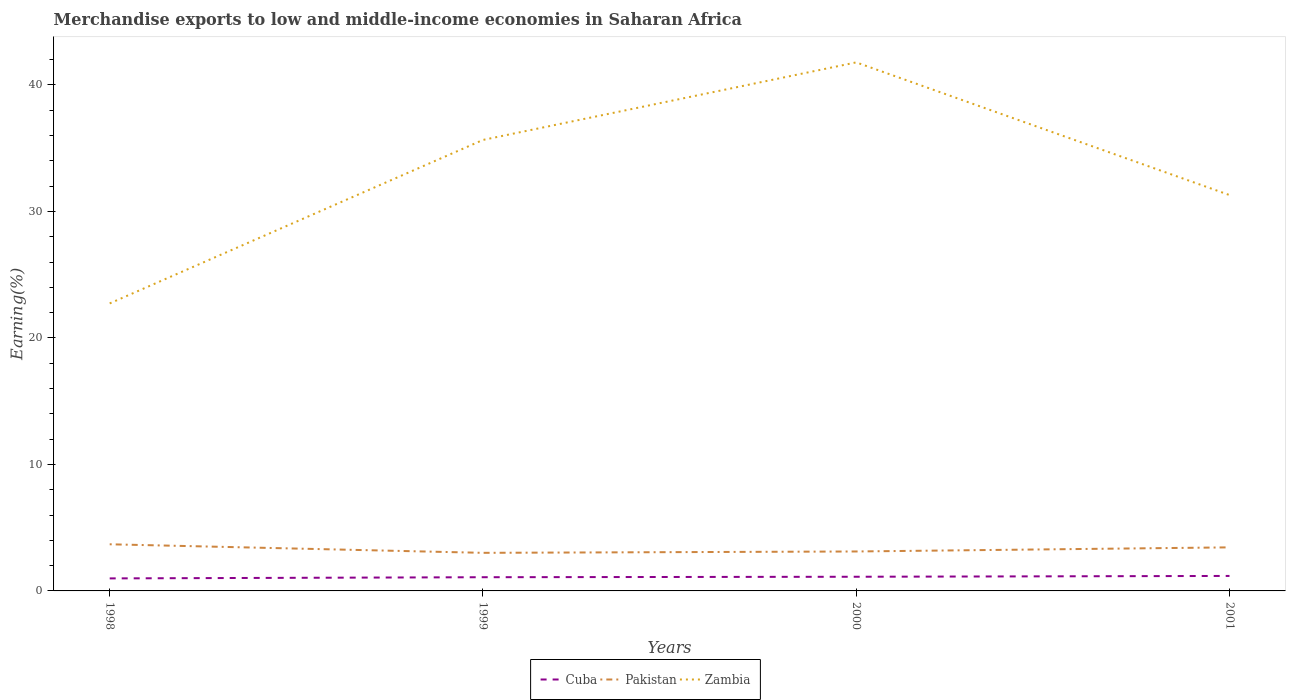How many different coloured lines are there?
Your response must be concise. 3. Is the number of lines equal to the number of legend labels?
Your answer should be compact. Yes. Across all years, what is the maximum percentage of amount earned from merchandise exports in Cuba?
Keep it short and to the point. 0.99. What is the total percentage of amount earned from merchandise exports in Pakistan in the graph?
Your answer should be compact. -0.43. What is the difference between the highest and the second highest percentage of amount earned from merchandise exports in Pakistan?
Keep it short and to the point. 0.68. What is the difference between the highest and the lowest percentage of amount earned from merchandise exports in Pakistan?
Give a very brief answer. 2. Is the percentage of amount earned from merchandise exports in Zambia strictly greater than the percentage of amount earned from merchandise exports in Cuba over the years?
Your answer should be very brief. No. How many lines are there?
Provide a succinct answer. 3. How many years are there in the graph?
Give a very brief answer. 4. What is the difference between two consecutive major ticks on the Y-axis?
Ensure brevity in your answer.  10. Does the graph contain any zero values?
Provide a succinct answer. No. Where does the legend appear in the graph?
Keep it short and to the point. Bottom center. What is the title of the graph?
Make the answer very short. Merchandise exports to low and middle-income economies in Saharan Africa. Does "Germany" appear as one of the legend labels in the graph?
Give a very brief answer. No. What is the label or title of the X-axis?
Your answer should be compact. Years. What is the label or title of the Y-axis?
Your answer should be very brief. Earning(%). What is the Earning(%) of Cuba in 1998?
Offer a terse response. 0.99. What is the Earning(%) in Pakistan in 1998?
Provide a short and direct response. 3.69. What is the Earning(%) in Zambia in 1998?
Offer a terse response. 22.73. What is the Earning(%) of Cuba in 1999?
Offer a terse response. 1.08. What is the Earning(%) in Pakistan in 1999?
Offer a terse response. 3.01. What is the Earning(%) of Zambia in 1999?
Offer a terse response. 35.65. What is the Earning(%) of Cuba in 2000?
Your answer should be compact. 1.12. What is the Earning(%) of Pakistan in 2000?
Make the answer very short. 3.12. What is the Earning(%) of Zambia in 2000?
Provide a succinct answer. 41.78. What is the Earning(%) in Cuba in 2001?
Offer a terse response. 1.18. What is the Earning(%) in Pakistan in 2001?
Offer a terse response. 3.44. What is the Earning(%) of Zambia in 2001?
Provide a succinct answer. 31.29. Across all years, what is the maximum Earning(%) in Cuba?
Offer a terse response. 1.18. Across all years, what is the maximum Earning(%) in Pakistan?
Offer a terse response. 3.69. Across all years, what is the maximum Earning(%) in Zambia?
Your answer should be very brief. 41.78. Across all years, what is the minimum Earning(%) of Cuba?
Your answer should be very brief. 0.99. Across all years, what is the minimum Earning(%) of Pakistan?
Your response must be concise. 3.01. Across all years, what is the minimum Earning(%) of Zambia?
Your answer should be very brief. 22.73. What is the total Earning(%) of Cuba in the graph?
Keep it short and to the point. 4.38. What is the total Earning(%) in Pakistan in the graph?
Make the answer very short. 13.26. What is the total Earning(%) in Zambia in the graph?
Provide a succinct answer. 131.45. What is the difference between the Earning(%) in Cuba in 1998 and that in 1999?
Your answer should be compact. -0.09. What is the difference between the Earning(%) in Pakistan in 1998 and that in 1999?
Offer a terse response. 0.68. What is the difference between the Earning(%) of Zambia in 1998 and that in 1999?
Give a very brief answer. -12.92. What is the difference between the Earning(%) in Cuba in 1998 and that in 2000?
Your response must be concise. -0.13. What is the difference between the Earning(%) in Pakistan in 1998 and that in 2000?
Offer a terse response. 0.57. What is the difference between the Earning(%) of Zambia in 1998 and that in 2000?
Ensure brevity in your answer.  -19.05. What is the difference between the Earning(%) of Cuba in 1998 and that in 2001?
Offer a very short reply. -0.19. What is the difference between the Earning(%) in Pakistan in 1998 and that in 2001?
Your answer should be very brief. 0.24. What is the difference between the Earning(%) in Zambia in 1998 and that in 2001?
Provide a short and direct response. -8.57. What is the difference between the Earning(%) in Cuba in 1999 and that in 2000?
Offer a very short reply. -0.04. What is the difference between the Earning(%) of Pakistan in 1999 and that in 2000?
Provide a short and direct response. -0.11. What is the difference between the Earning(%) in Zambia in 1999 and that in 2000?
Offer a very short reply. -6.13. What is the difference between the Earning(%) in Cuba in 1999 and that in 2001?
Make the answer very short. -0.1. What is the difference between the Earning(%) of Pakistan in 1999 and that in 2001?
Your answer should be compact. -0.43. What is the difference between the Earning(%) of Zambia in 1999 and that in 2001?
Provide a short and direct response. 4.36. What is the difference between the Earning(%) of Cuba in 2000 and that in 2001?
Provide a succinct answer. -0.06. What is the difference between the Earning(%) in Pakistan in 2000 and that in 2001?
Offer a terse response. -0.32. What is the difference between the Earning(%) of Zambia in 2000 and that in 2001?
Your response must be concise. 10.49. What is the difference between the Earning(%) of Cuba in 1998 and the Earning(%) of Pakistan in 1999?
Ensure brevity in your answer.  -2.02. What is the difference between the Earning(%) of Cuba in 1998 and the Earning(%) of Zambia in 1999?
Give a very brief answer. -34.66. What is the difference between the Earning(%) of Pakistan in 1998 and the Earning(%) of Zambia in 1999?
Ensure brevity in your answer.  -31.96. What is the difference between the Earning(%) in Cuba in 1998 and the Earning(%) in Pakistan in 2000?
Your response must be concise. -2.13. What is the difference between the Earning(%) of Cuba in 1998 and the Earning(%) of Zambia in 2000?
Give a very brief answer. -40.79. What is the difference between the Earning(%) in Pakistan in 1998 and the Earning(%) in Zambia in 2000?
Provide a succinct answer. -38.09. What is the difference between the Earning(%) in Cuba in 1998 and the Earning(%) in Pakistan in 2001?
Your answer should be compact. -2.45. What is the difference between the Earning(%) of Cuba in 1998 and the Earning(%) of Zambia in 2001?
Keep it short and to the point. -30.3. What is the difference between the Earning(%) in Pakistan in 1998 and the Earning(%) in Zambia in 2001?
Provide a succinct answer. -27.61. What is the difference between the Earning(%) in Cuba in 1999 and the Earning(%) in Pakistan in 2000?
Ensure brevity in your answer.  -2.04. What is the difference between the Earning(%) in Cuba in 1999 and the Earning(%) in Zambia in 2000?
Offer a very short reply. -40.7. What is the difference between the Earning(%) in Pakistan in 1999 and the Earning(%) in Zambia in 2000?
Provide a short and direct response. -38.77. What is the difference between the Earning(%) of Cuba in 1999 and the Earning(%) of Pakistan in 2001?
Keep it short and to the point. -2.36. What is the difference between the Earning(%) of Cuba in 1999 and the Earning(%) of Zambia in 2001?
Your answer should be very brief. -30.21. What is the difference between the Earning(%) of Pakistan in 1999 and the Earning(%) of Zambia in 2001?
Offer a very short reply. -28.28. What is the difference between the Earning(%) in Cuba in 2000 and the Earning(%) in Pakistan in 2001?
Offer a terse response. -2.32. What is the difference between the Earning(%) in Cuba in 2000 and the Earning(%) in Zambia in 2001?
Ensure brevity in your answer.  -30.17. What is the difference between the Earning(%) in Pakistan in 2000 and the Earning(%) in Zambia in 2001?
Give a very brief answer. -28.17. What is the average Earning(%) of Cuba per year?
Your answer should be compact. 1.09. What is the average Earning(%) of Pakistan per year?
Make the answer very short. 3.31. What is the average Earning(%) of Zambia per year?
Make the answer very short. 32.86. In the year 1998, what is the difference between the Earning(%) in Cuba and Earning(%) in Pakistan?
Ensure brevity in your answer.  -2.7. In the year 1998, what is the difference between the Earning(%) of Cuba and Earning(%) of Zambia?
Make the answer very short. -21.74. In the year 1998, what is the difference between the Earning(%) in Pakistan and Earning(%) in Zambia?
Provide a short and direct response. -19.04. In the year 1999, what is the difference between the Earning(%) of Cuba and Earning(%) of Pakistan?
Keep it short and to the point. -1.93. In the year 1999, what is the difference between the Earning(%) of Cuba and Earning(%) of Zambia?
Your answer should be compact. -34.57. In the year 1999, what is the difference between the Earning(%) in Pakistan and Earning(%) in Zambia?
Your answer should be compact. -32.64. In the year 2000, what is the difference between the Earning(%) of Cuba and Earning(%) of Pakistan?
Provide a succinct answer. -2. In the year 2000, what is the difference between the Earning(%) of Cuba and Earning(%) of Zambia?
Offer a very short reply. -40.66. In the year 2000, what is the difference between the Earning(%) in Pakistan and Earning(%) in Zambia?
Ensure brevity in your answer.  -38.66. In the year 2001, what is the difference between the Earning(%) in Cuba and Earning(%) in Pakistan?
Your response must be concise. -2.26. In the year 2001, what is the difference between the Earning(%) in Cuba and Earning(%) in Zambia?
Ensure brevity in your answer.  -30.11. In the year 2001, what is the difference between the Earning(%) of Pakistan and Earning(%) of Zambia?
Provide a short and direct response. -27.85. What is the ratio of the Earning(%) in Cuba in 1998 to that in 1999?
Provide a succinct answer. 0.91. What is the ratio of the Earning(%) in Pakistan in 1998 to that in 1999?
Your answer should be very brief. 1.22. What is the ratio of the Earning(%) in Zambia in 1998 to that in 1999?
Ensure brevity in your answer.  0.64. What is the ratio of the Earning(%) of Cuba in 1998 to that in 2000?
Offer a terse response. 0.88. What is the ratio of the Earning(%) in Pakistan in 1998 to that in 2000?
Your response must be concise. 1.18. What is the ratio of the Earning(%) of Zambia in 1998 to that in 2000?
Offer a very short reply. 0.54. What is the ratio of the Earning(%) in Cuba in 1998 to that in 2001?
Make the answer very short. 0.84. What is the ratio of the Earning(%) in Pakistan in 1998 to that in 2001?
Your answer should be compact. 1.07. What is the ratio of the Earning(%) in Zambia in 1998 to that in 2001?
Offer a terse response. 0.73. What is the ratio of the Earning(%) of Cuba in 1999 to that in 2000?
Give a very brief answer. 0.97. What is the ratio of the Earning(%) of Pakistan in 1999 to that in 2000?
Offer a terse response. 0.97. What is the ratio of the Earning(%) in Zambia in 1999 to that in 2000?
Provide a short and direct response. 0.85. What is the ratio of the Earning(%) of Cuba in 1999 to that in 2001?
Offer a terse response. 0.91. What is the ratio of the Earning(%) of Pakistan in 1999 to that in 2001?
Offer a terse response. 0.87. What is the ratio of the Earning(%) in Zambia in 1999 to that in 2001?
Provide a succinct answer. 1.14. What is the ratio of the Earning(%) in Cuba in 2000 to that in 2001?
Give a very brief answer. 0.95. What is the ratio of the Earning(%) in Pakistan in 2000 to that in 2001?
Keep it short and to the point. 0.91. What is the ratio of the Earning(%) in Zambia in 2000 to that in 2001?
Offer a very short reply. 1.34. What is the difference between the highest and the second highest Earning(%) of Cuba?
Your answer should be compact. 0.06. What is the difference between the highest and the second highest Earning(%) of Pakistan?
Provide a succinct answer. 0.24. What is the difference between the highest and the second highest Earning(%) in Zambia?
Give a very brief answer. 6.13. What is the difference between the highest and the lowest Earning(%) in Cuba?
Offer a terse response. 0.19. What is the difference between the highest and the lowest Earning(%) of Pakistan?
Keep it short and to the point. 0.68. What is the difference between the highest and the lowest Earning(%) in Zambia?
Your response must be concise. 19.05. 